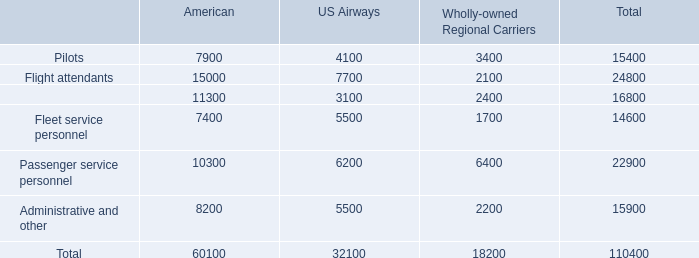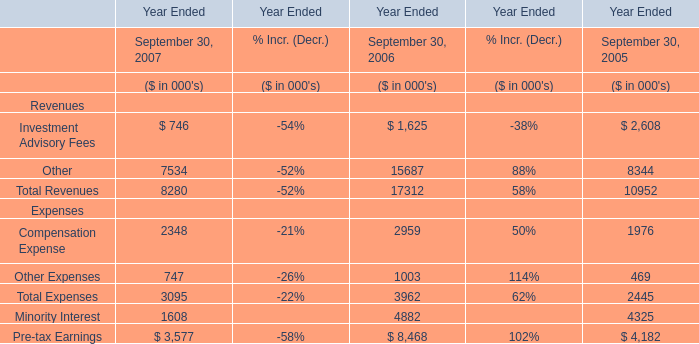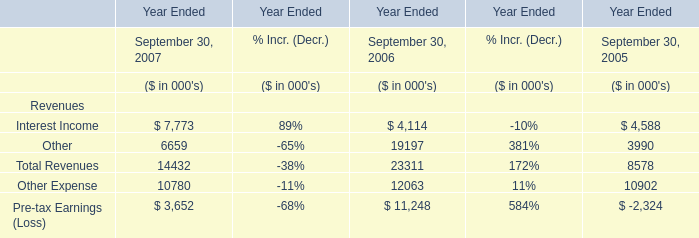As As the chart 1 shows,which Year Ended September 30 is Compensation Expense the highest? 
Answer: 2006. 